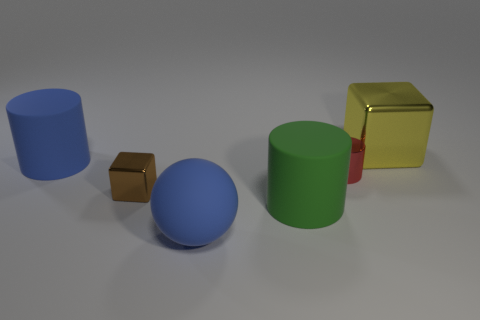Subtract all blue matte cylinders. How many cylinders are left? 2 Subtract 3 cylinders. How many cylinders are left? 0 Add 2 blue cylinders. How many objects exist? 8 Subtract all red cylinders. How many cylinders are left? 2 Subtract all cyan blocks. Subtract all cyan cylinders. How many blocks are left? 2 Subtract all large blue cylinders. Subtract all big yellow things. How many objects are left? 4 Add 3 red objects. How many red objects are left? 4 Add 3 large blue rubber spheres. How many large blue rubber spheres exist? 4 Subtract 0 gray cylinders. How many objects are left? 6 Subtract all cubes. How many objects are left? 4 